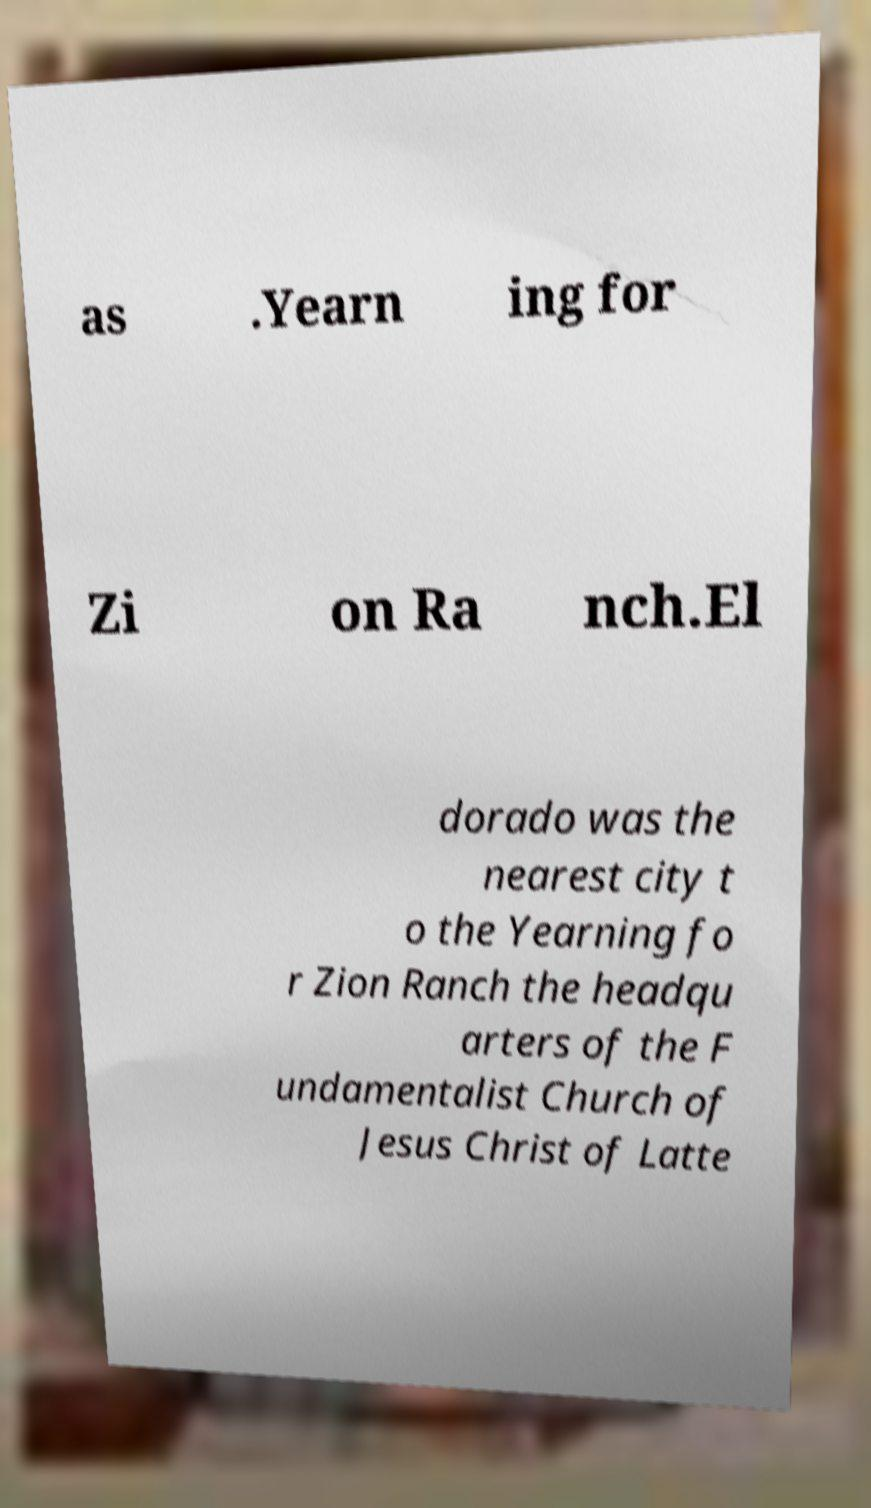Could you assist in decoding the text presented in this image and type it out clearly? as .Yearn ing for Zi on Ra nch.El dorado was the nearest city t o the Yearning fo r Zion Ranch the headqu arters of the F undamentalist Church of Jesus Christ of Latte 